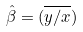<formula> <loc_0><loc_0><loc_500><loc_500>\hat { \beta } = ( \overline { y / x } )</formula> 